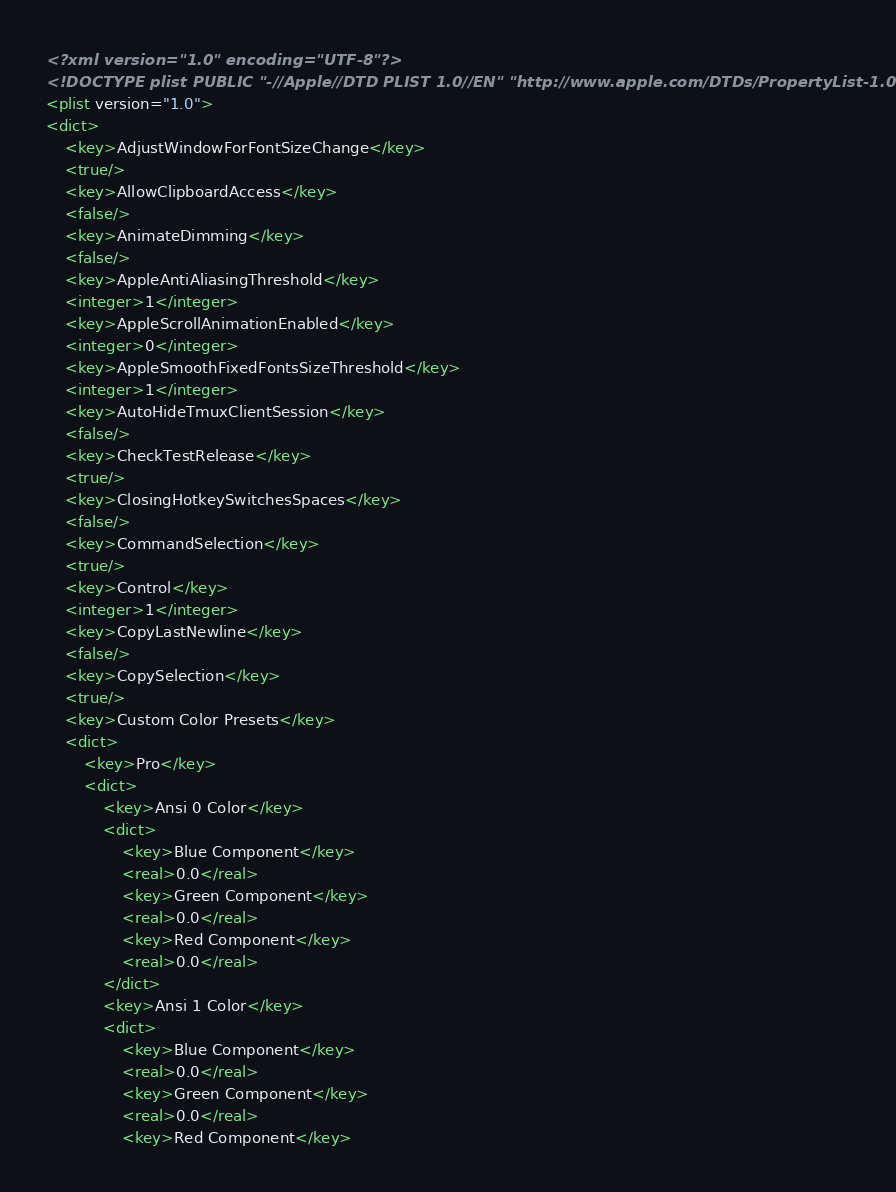Convert code to text. <code><loc_0><loc_0><loc_500><loc_500><_XML_><?xml version="1.0" encoding="UTF-8"?>
<!DOCTYPE plist PUBLIC "-//Apple//DTD PLIST 1.0//EN" "http://www.apple.com/DTDs/PropertyList-1.0.dtd">
<plist version="1.0">
<dict>
	<key>AdjustWindowForFontSizeChange</key>
	<true/>
	<key>AllowClipboardAccess</key>
	<false/>
	<key>AnimateDimming</key>
	<false/>
	<key>AppleAntiAliasingThreshold</key>
	<integer>1</integer>
	<key>AppleScrollAnimationEnabled</key>
	<integer>0</integer>
	<key>AppleSmoothFixedFontsSizeThreshold</key>
	<integer>1</integer>
	<key>AutoHideTmuxClientSession</key>
	<false/>
	<key>CheckTestRelease</key>
	<true/>
	<key>ClosingHotkeySwitchesSpaces</key>
	<false/>
	<key>CommandSelection</key>
	<true/>
	<key>Control</key>
	<integer>1</integer>
	<key>CopyLastNewline</key>
	<false/>
	<key>CopySelection</key>
	<true/>
	<key>Custom Color Presets</key>
	<dict>
		<key>Pro</key>
		<dict>
			<key>Ansi 0 Color</key>
			<dict>
				<key>Blue Component</key>
				<real>0.0</real>
				<key>Green Component</key>
				<real>0.0</real>
				<key>Red Component</key>
				<real>0.0</real>
			</dict>
			<key>Ansi 1 Color</key>
			<dict>
				<key>Blue Component</key>
				<real>0.0</real>
				<key>Green Component</key>
				<real>0.0</real>
				<key>Red Component</key></code> 